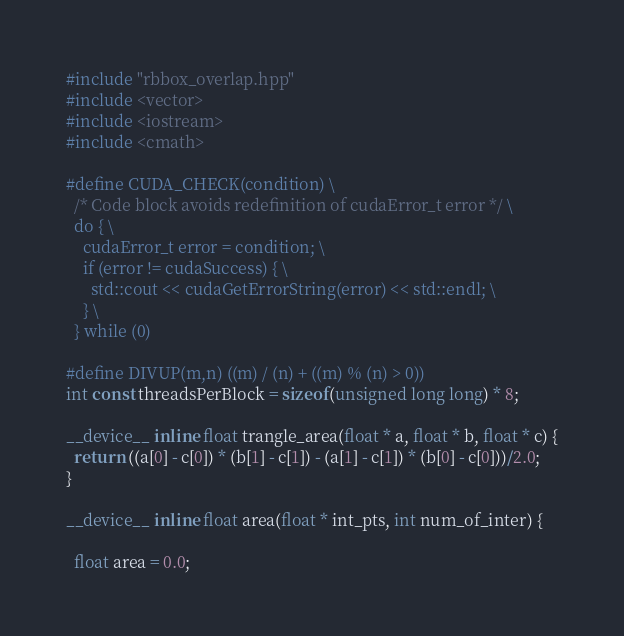Convert code to text. <code><loc_0><loc_0><loc_500><loc_500><_Cuda_>
#include "rbbox_overlap.hpp"
#include <vector>
#include <iostream>
#include <cmath>

#define CUDA_CHECK(condition) \
  /* Code block avoids redefinition of cudaError_t error */ \
  do { \
    cudaError_t error = condition; \
    if (error != cudaSuccess) { \
      std::cout << cudaGetErrorString(error) << std::endl; \
    } \
  } while (0)

#define DIVUP(m,n) ((m) / (n) + ((m) % (n) > 0))
int const threadsPerBlock = sizeof(unsigned long long) * 8;

__device__ inline float trangle_area(float * a, float * b, float * c) {
  return ((a[0] - c[0]) * (b[1] - c[1]) - (a[1] - c[1]) * (b[0] - c[0]))/2.0;
}

__device__ inline float area(float * int_pts, int num_of_inter) {

  float area = 0.0;</code> 